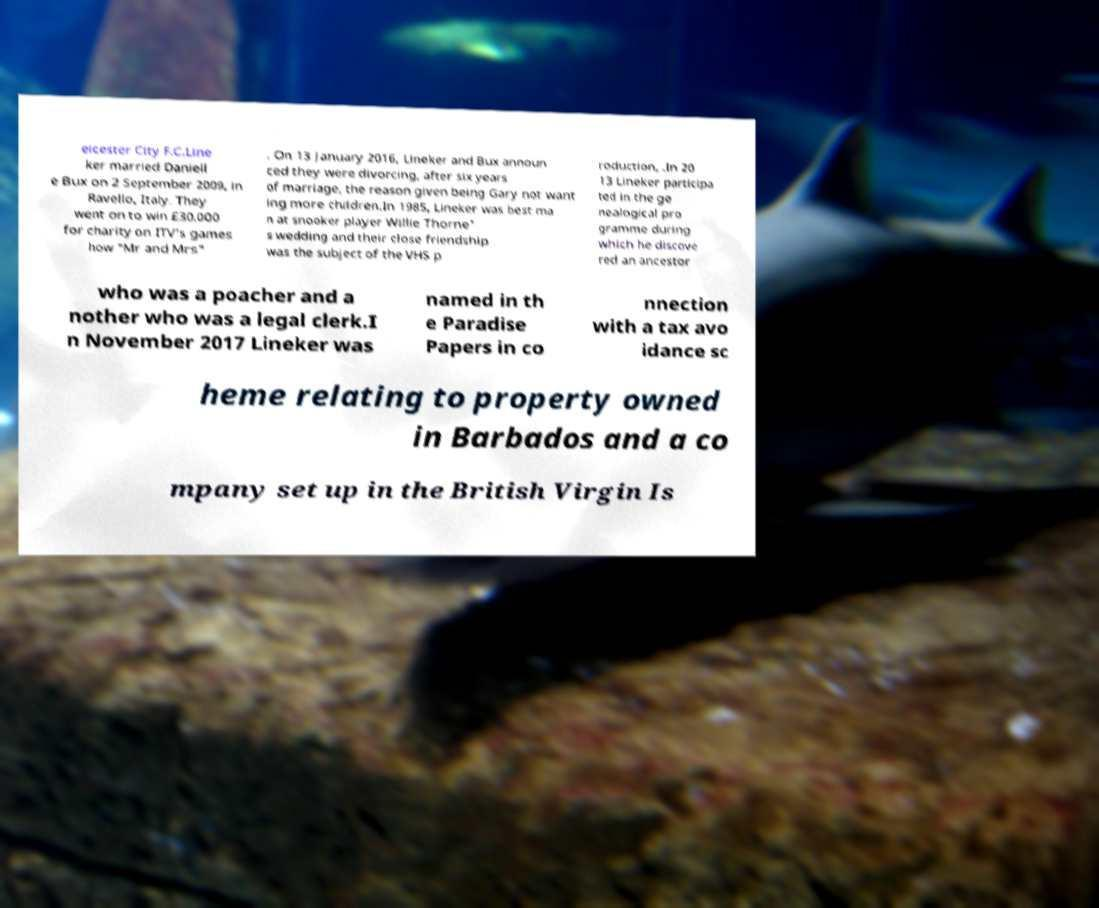Please read and relay the text visible in this image. What does it say? eicester City F.C.Line ker married Daniell e Bux on 2 September 2009, in Ravello, Italy. They went on to win £30,000 for charity on ITV's games how "Mr and Mrs" . On 13 January 2016, Lineker and Bux announ ced they were divorcing, after six years of marriage, the reason given being Gary not want ing more children.In 1985, Lineker was best ma n at snooker player Willie Thorne' s wedding and their close friendship was the subject of the VHS p roduction, .In 20 13 Lineker participa ted in the ge nealogical pro gramme during which he discove red an ancestor who was a poacher and a nother who was a legal clerk.I n November 2017 Lineker was named in th e Paradise Papers in co nnection with a tax avo idance sc heme relating to property owned in Barbados and a co mpany set up in the British Virgin Is 